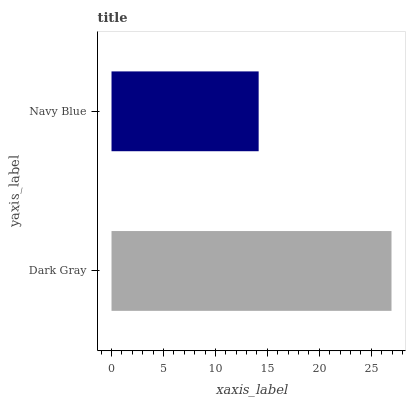Is Navy Blue the minimum?
Answer yes or no. Yes. Is Dark Gray the maximum?
Answer yes or no. Yes. Is Navy Blue the maximum?
Answer yes or no. No. Is Dark Gray greater than Navy Blue?
Answer yes or no. Yes. Is Navy Blue less than Dark Gray?
Answer yes or no. Yes. Is Navy Blue greater than Dark Gray?
Answer yes or no. No. Is Dark Gray less than Navy Blue?
Answer yes or no. No. Is Dark Gray the high median?
Answer yes or no. Yes. Is Navy Blue the low median?
Answer yes or no. Yes. Is Navy Blue the high median?
Answer yes or no. No. Is Dark Gray the low median?
Answer yes or no. No. 